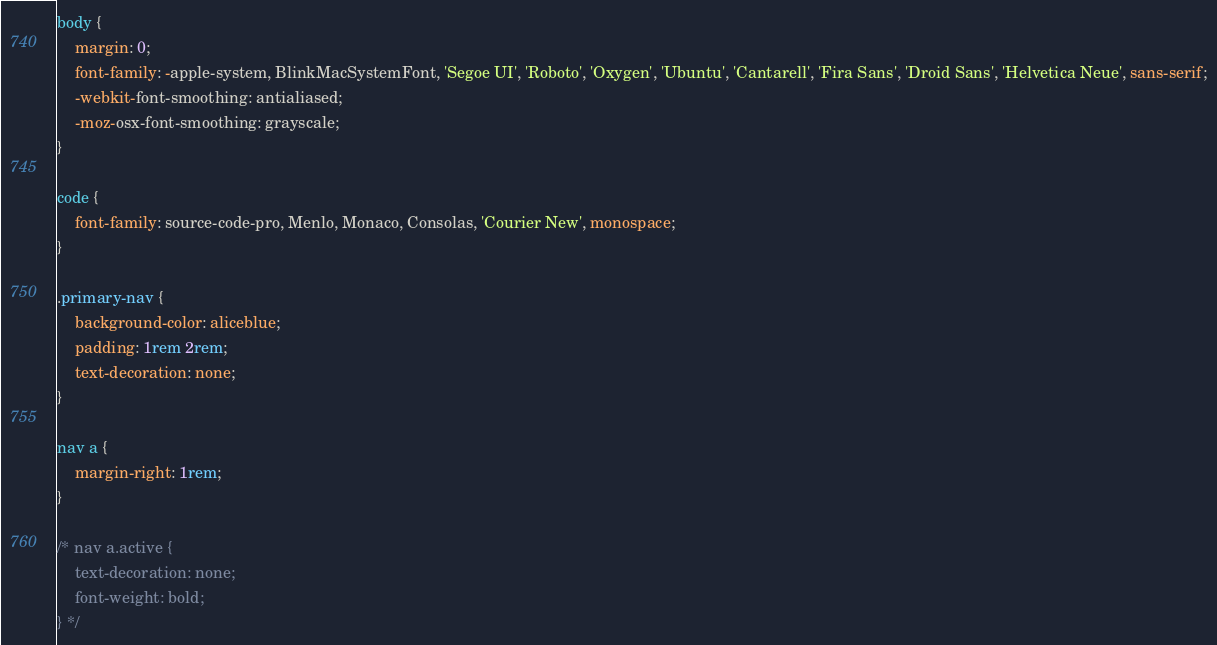Convert code to text. <code><loc_0><loc_0><loc_500><loc_500><_CSS_>body {
	margin: 0;
	font-family: -apple-system, BlinkMacSystemFont, 'Segoe UI', 'Roboto', 'Oxygen', 'Ubuntu', 'Cantarell', 'Fira Sans', 'Droid Sans', 'Helvetica Neue', sans-serif;
	-webkit-font-smoothing: antialiased;
	-moz-osx-font-smoothing: grayscale;
}

code {
	font-family: source-code-pro, Menlo, Monaco, Consolas, 'Courier New', monospace;
}

.primary-nav {
	background-color: aliceblue;
	padding: 1rem 2rem;
	text-decoration: none;
}

nav a {
	margin-right: 1rem;
}

/* nav a.active {
	text-decoration: none;
	font-weight: bold;
} */</code> 